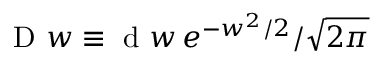Convert formula to latex. <formula><loc_0><loc_0><loc_500><loc_500>D w \equiv d w \, e ^ { - w ^ { 2 } / 2 } / \sqrt { 2 \pi }</formula> 